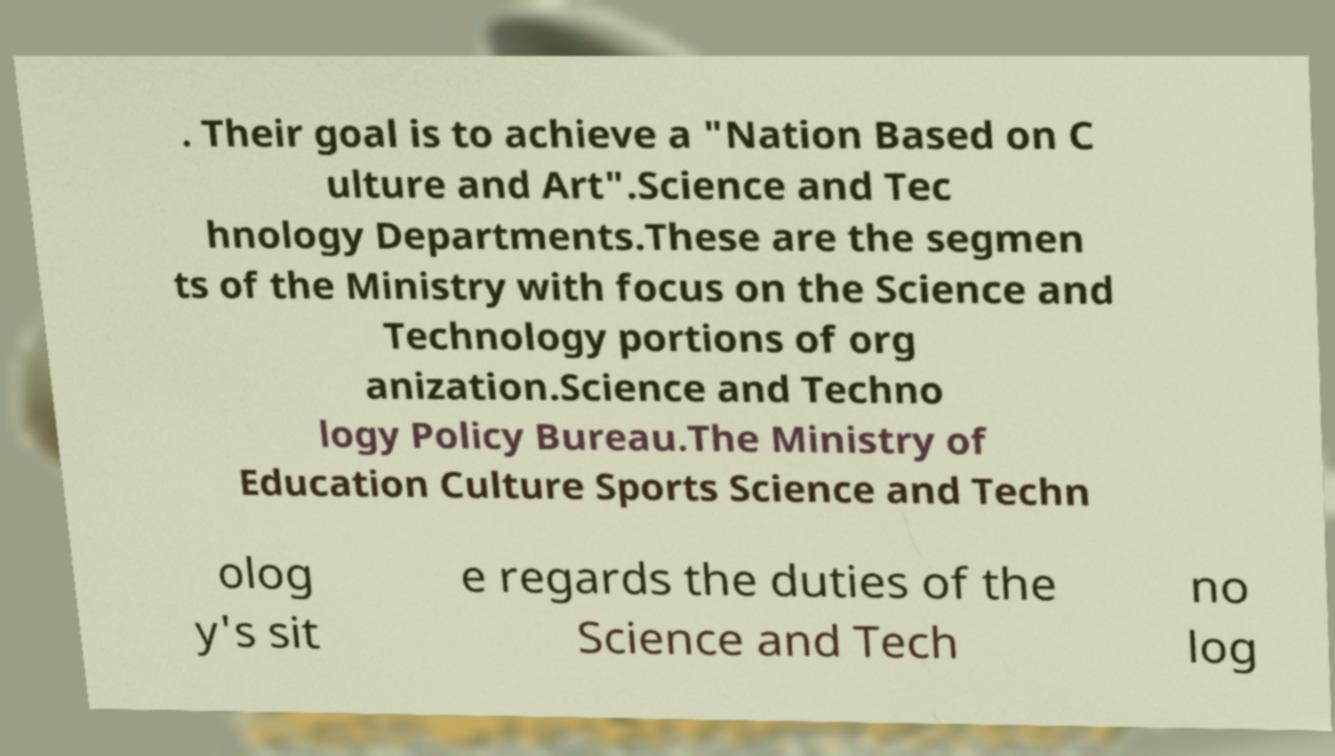Can you accurately transcribe the text from the provided image for me? . Their goal is to achieve a "Nation Based on C ulture and Art".Science and Tec hnology Departments.These are the segmen ts of the Ministry with focus on the Science and Technology portions of org anization.Science and Techno logy Policy Bureau.The Ministry of Education Culture Sports Science and Techn olog y's sit e regards the duties of the Science and Tech no log 